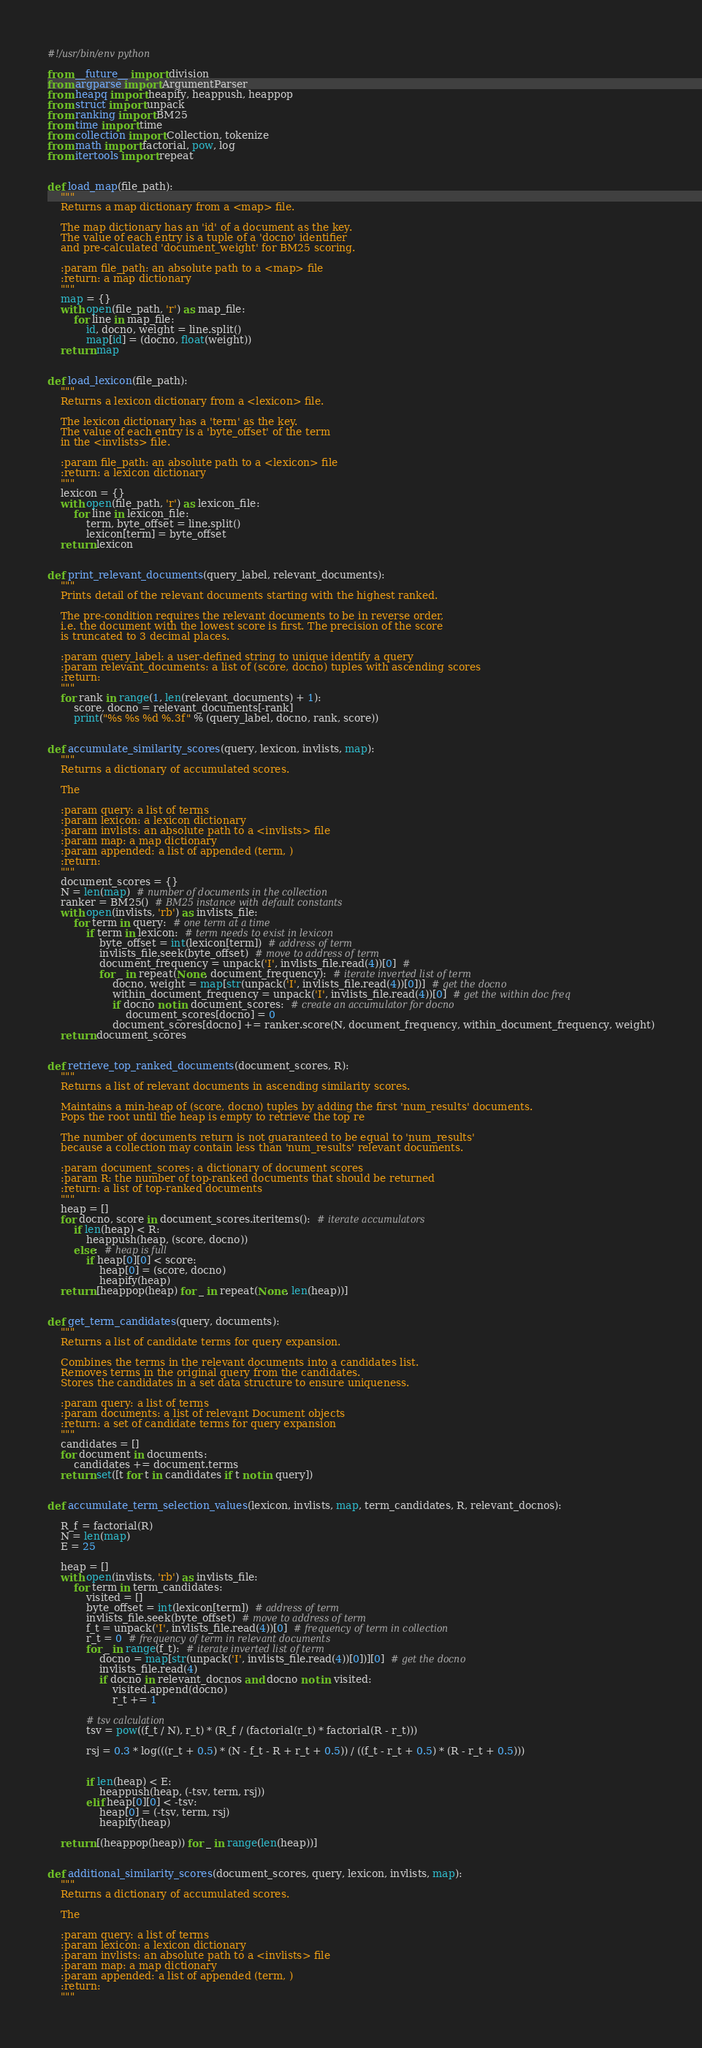Convert code to text. <code><loc_0><loc_0><loc_500><loc_500><_Python_>#!/usr/bin/env python

from __future__ import division
from argparse import ArgumentParser
from heapq import heapify, heappush, heappop
from struct import unpack
from ranking import BM25
from time import time
from collection import Collection, tokenize
from math import factorial, pow, log
from itertools import repeat


def load_map(file_path):
    """
    Returns a map dictionary from a <map> file.

    The map dictionary has an 'id' of a document as the key.
    The value of each entry is a tuple of a 'docno' identifier
    and pre-calculated 'document_weight' for BM25 scoring.

    :param file_path: an absolute path to a <map> file
    :return: a map dictionary
    """
    map = {}
    with open(file_path, 'r') as map_file:
        for line in map_file:
            id, docno, weight = line.split()
            map[id] = (docno, float(weight))
    return map


def load_lexicon(file_path):
    """
    Returns a lexicon dictionary from a <lexicon> file.

    The lexicon dictionary has a 'term' as the key.
    The value of each entry is a 'byte_offset' of the term
    in the <invlists> file.

    :param file_path: an absolute path to a <lexicon> file
    :return: a lexicon dictionary
    """
    lexicon = {}
    with open(file_path, 'r') as lexicon_file:
        for line in lexicon_file:
            term, byte_offset = line.split()
            lexicon[term] = byte_offset
    return lexicon


def print_relevant_documents(query_label, relevant_documents):
    """
    Prints detail of the relevant documents starting with the highest ranked.

    The pre-condition requires the relevant documents to be in reverse order,
    i.e. the document with the lowest score is first. The precision of the score
    is truncated to 3 decimal places.

    :param query_label: a user-defined string to unique identify a query
    :param relevant_documents: a list of (score, docno) tuples with ascending scores
    :return:
    """
    for rank in range(1, len(relevant_documents) + 1):
        score, docno = relevant_documents[-rank]
        print("%s %s %d %.3f" % (query_label, docno, rank, score))


def accumulate_similarity_scores(query, lexicon, invlists, map):
    """
    Returns a dictionary of accumulated scores.

    The
    
    :param query: a list of terms
    :param lexicon: a lexicon dictionary
    :param invlists: an absolute path to a <invlists> file
    :param map: a map dictionary
    :param appended: a list of appended (term, )
    :return: 
    """
    document_scores = {}
    N = len(map)  # number of documents in the collection
    ranker = BM25()  # BM25 instance with default constants
    with open(invlists, 'rb') as invlists_file:
        for term in query:  # one term at a time
            if term in lexicon:  # term needs to exist in lexicon
                byte_offset = int(lexicon[term])  # address of term
                invlists_file.seek(byte_offset)  # move to address of term
                document_frequency = unpack('I', invlists_file.read(4))[0]  #
                for _ in repeat(None, document_frequency):  # iterate inverted list of term
                    docno, weight = map[str(unpack('I', invlists_file.read(4))[0])]  # get the docno
                    within_document_frequency = unpack('I', invlists_file.read(4))[0]  # get the within doc freq
                    if docno not in document_scores:  # create an accumulator for docno
                        document_scores[docno] = 0
                    document_scores[docno] += ranker.score(N, document_frequency, within_document_frequency, weight)
    return document_scores


def retrieve_top_ranked_documents(document_scores, R):
    """
    Returns a list of relevant documents in ascending similarity scores.

    Maintains a min-heap of (score, docno) tuples by adding the first 'num_results' documents.
    Pops the root until the heap is empty to retrieve the top re

    The number of documents return is not guaranteed to be equal to 'num_results'
    because a collection may contain less than 'num_results' relevant documents.

    :param document_scores: a dictionary of document scores
    :param R: the number of top-ranked documents that should be returned
    :return: a list of top-ranked documents
    """
    heap = []
    for docno, score in document_scores.iteritems():  # iterate accumulators
        if len(heap) < R:
            heappush(heap, (score, docno))
        else:  # heap is full
            if heap[0][0] < score:
                heap[0] = (score, docno)
                heapify(heap)
    return [heappop(heap) for _ in repeat(None, len(heap))]


def get_term_candidates(query, documents):
    """
    Returns a list of candidate terms for query expansion.

    Combines the terms in the relevant documents into a candidates list.
    Removes terms in the original query from the candidates.
    Stores the candidates in a set data structure to ensure uniqueness.

    :param query: a list of terms
    :param documents: a list of relevant Document objects
    :return: a set of candidate terms for query expansion
    """
    candidates = []
    for document in documents:
        candidates += document.terms
    return set([t for t in candidates if t not in query])


def accumulate_term_selection_values(lexicon, invlists, map, term_candidates, R, relevant_docnos):

    R_f = factorial(R)
    N = len(map)
    E = 25

    heap = []
    with open(invlists, 'rb') as invlists_file:
        for term in term_candidates:
            visited = []
            byte_offset = int(lexicon[term])  # address of term
            invlists_file.seek(byte_offset)  # move to address of term
            f_t = unpack('I', invlists_file.read(4))[0]  # frequency of term in collection
            r_t = 0  # frequency of term in relevant documents
            for _ in range(f_t):  # iterate inverted list of term
                docno = map[str(unpack('I', invlists_file.read(4))[0])][0]  # get the docno
                invlists_file.read(4)
                if docno in relevant_docnos and docno not in visited:
                    visited.append(docno)
                    r_t += 1

            # tsv calculation
            tsv = pow((f_t / N), r_t) * (R_f / (factorial(r_t) * factorial(R - r_t)))

            rsj = 0.3 * log(((r_t + 0.5) * (N - f_t - R + r_t + 0.5)) / ((f_t - r_t + 0.5) * (R - r_t + 0.5)))


            if len(heap) < E:
                heappush(heap, (-tsv, term, rsj))
            elif heap[0][0] < -tsv:
                heap[0] = (-tsv, term, rsj)
                heapify(heap)

    return [(heappop(heap)) for _ in range(len(heap))]


def additional_similarity_scores(document_scores, query, lexicon, invlists, map):
    """
    Returns a dictionary of accumulated scores.

    The

    :param query: a list of terms
    :param lexicon: a lexicon dictionary
    :param invlists: an absolute path to a <invlists> file
    :param map: a map dictionary
    :param appended: a list of appended (term, )
    :return:
    """</code> 